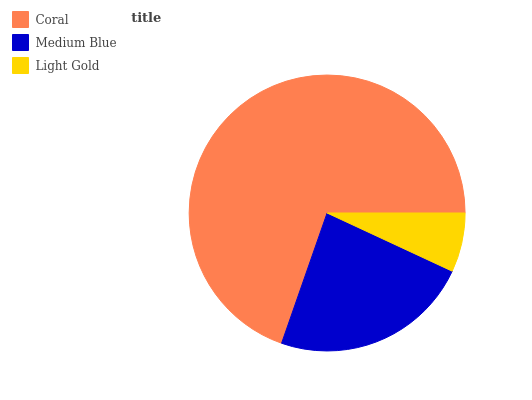Is Light Gold the minimum?
Answer yes or no. Yes. Is Coral the maximum?
Answer yes or no. Yes. Is Medium Blue the minimum?
Answer yes or no. No. Is Medium Blue the maximum?
Answer yes or no. No. Is Coral greater than Medium Blue?
Answer yes or no. Yes. Is Medium Blue less than Coral?
Answer yes or no. Yes. Is Medium Blue greater than Coral?
Answer yes or no. No. Is Coral less than Medium Blue?
Answer yes or no. No. Is Medium Blue the high median?
Answer yes or no. Yes. Is Medium Blue the low median?
Answer yes or no. Yes. Is Light Gold the high median?
Answer yes or no. No. Is Light Gold the low median?
Answer yes or no. No. 